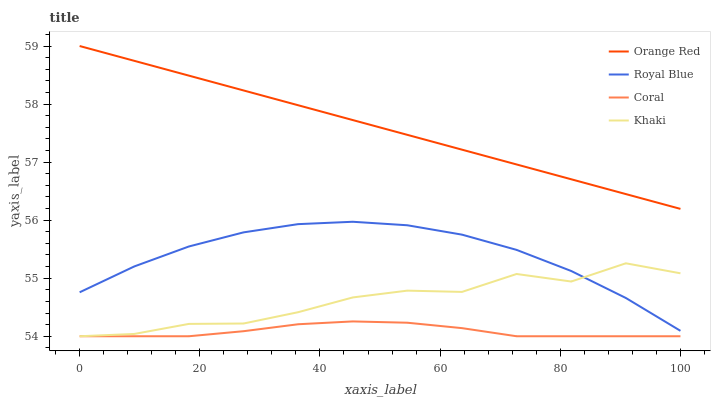Does Khaki have the minimum area under the curve?
Answer yes or no. No. Does Khaki have the maximum area under the curve?
Answer yes or no. No. Is Coral the smoothest?
Answer yes or no. No. Is Coral the roughest?
Answer yes or no. No. Does Orange Red have the lowest value?
Answer yes or no. No. Does Khaki have the highest value?
Answer yes or no. No. Is Coral less than Orange Red?
Answer yes or no. Yes. Is Royal Blue greater than Coral?
Answer yes or no. Yes. Does Coral intersect Orange Red?
Answer yes or no. No. 